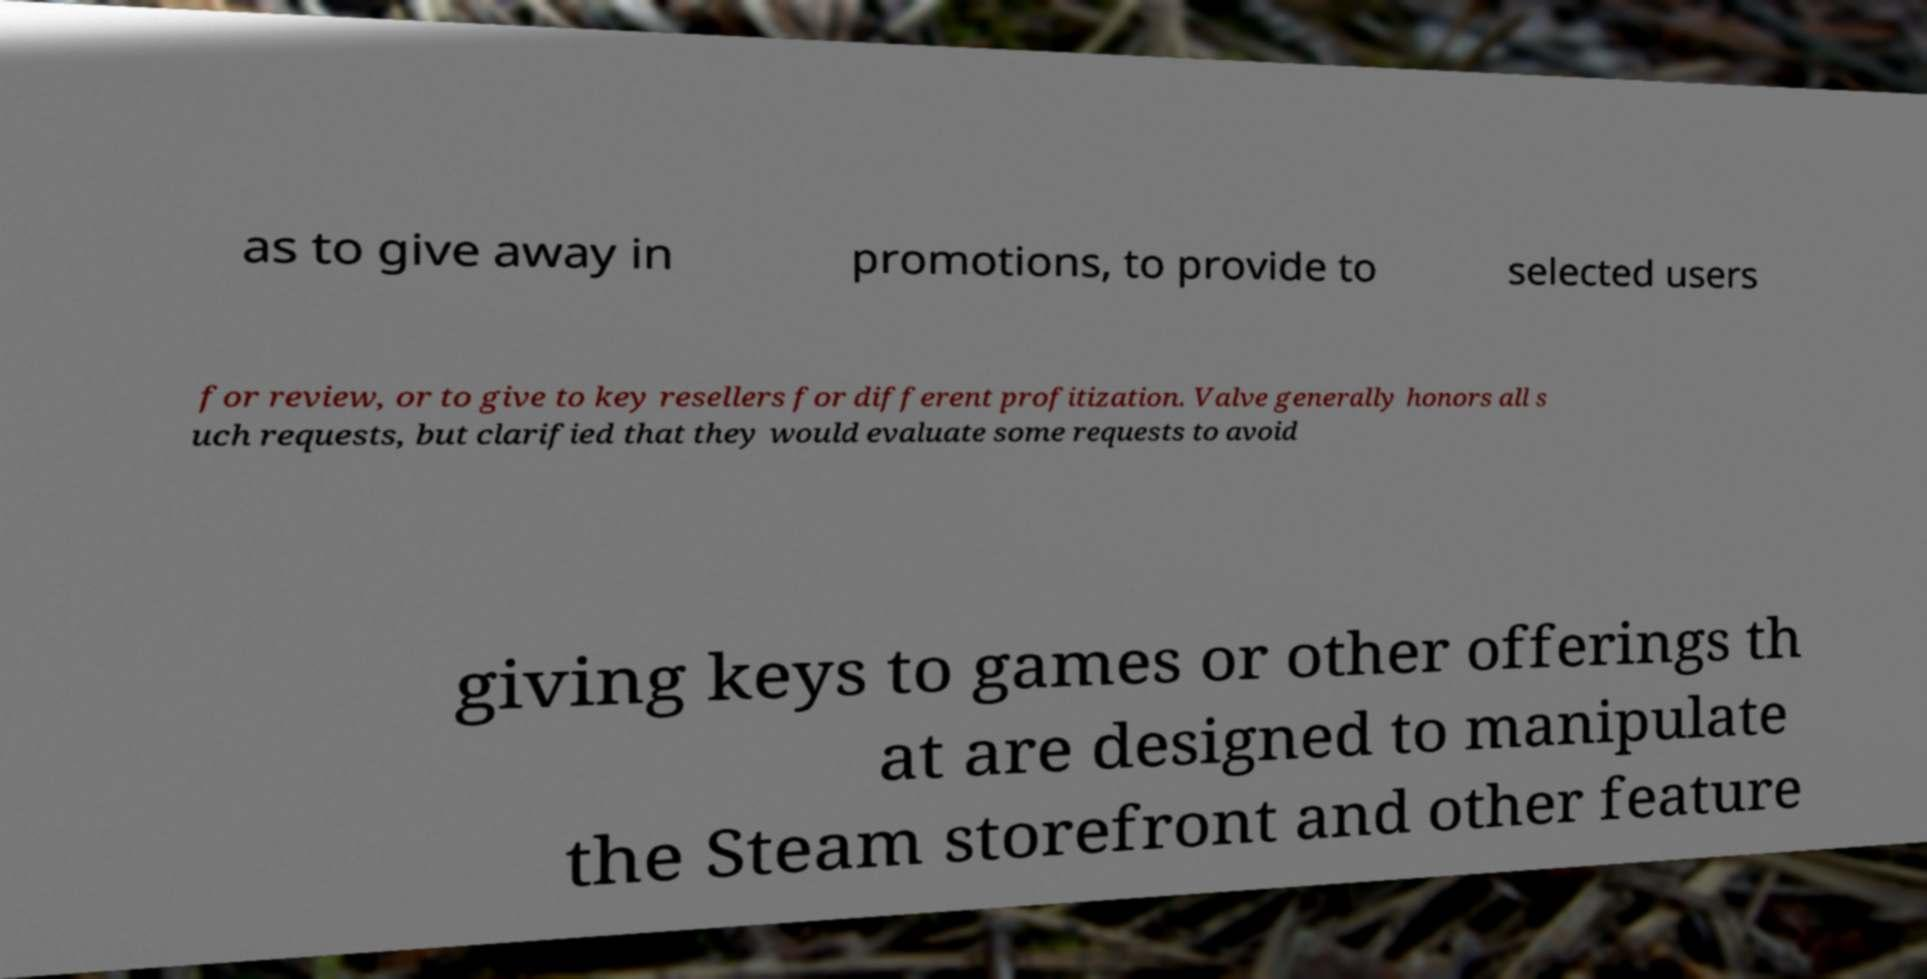For documentation purposes, I need the text within this image transcribed. Could you provide that? as to give away in promotions, to provide to selected users for review, or to give to key resellers for different profitization. Valve generally honors all s uch requests, but clarified that they would evaluate some requests to avoid giving keys to games or other offerings th at are designed to manipulate the Steam storefront and other feature 